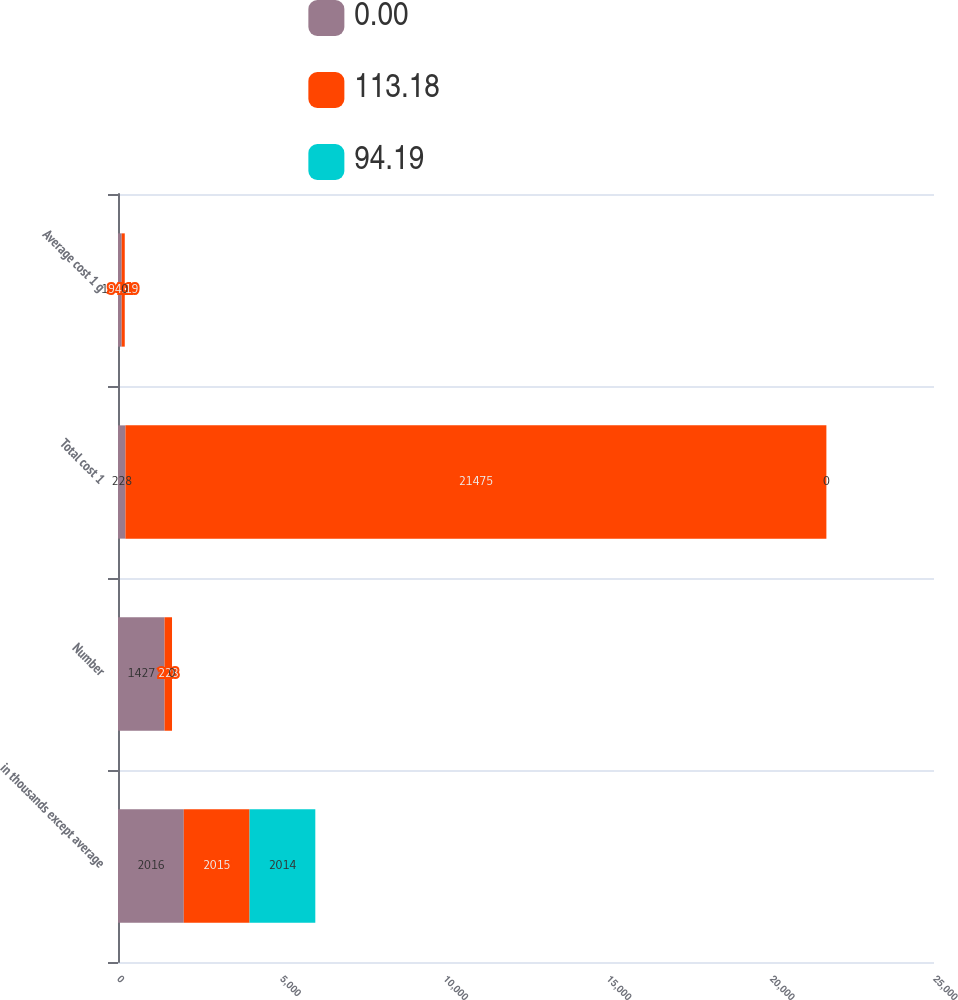Convert chart. <chart><loc_0><loc_0><loc_500><loc_500><stacked_bar_chart><ecel><fcel>in thousands except average<fcel>Number<fcel>Total cost 1<fcel>Average cost 1 g<nl><fcel>0<fcel>2016<fcel>1427<fcel>228<fcel>113.18<nl><fcel>113.18<fcel>2015<fcel>228<fcel>21475<fcel>94.19<nl><fcel>94.19<fcel>2014<fcel>0<fcel>0<fcel>0<nl></chart> 